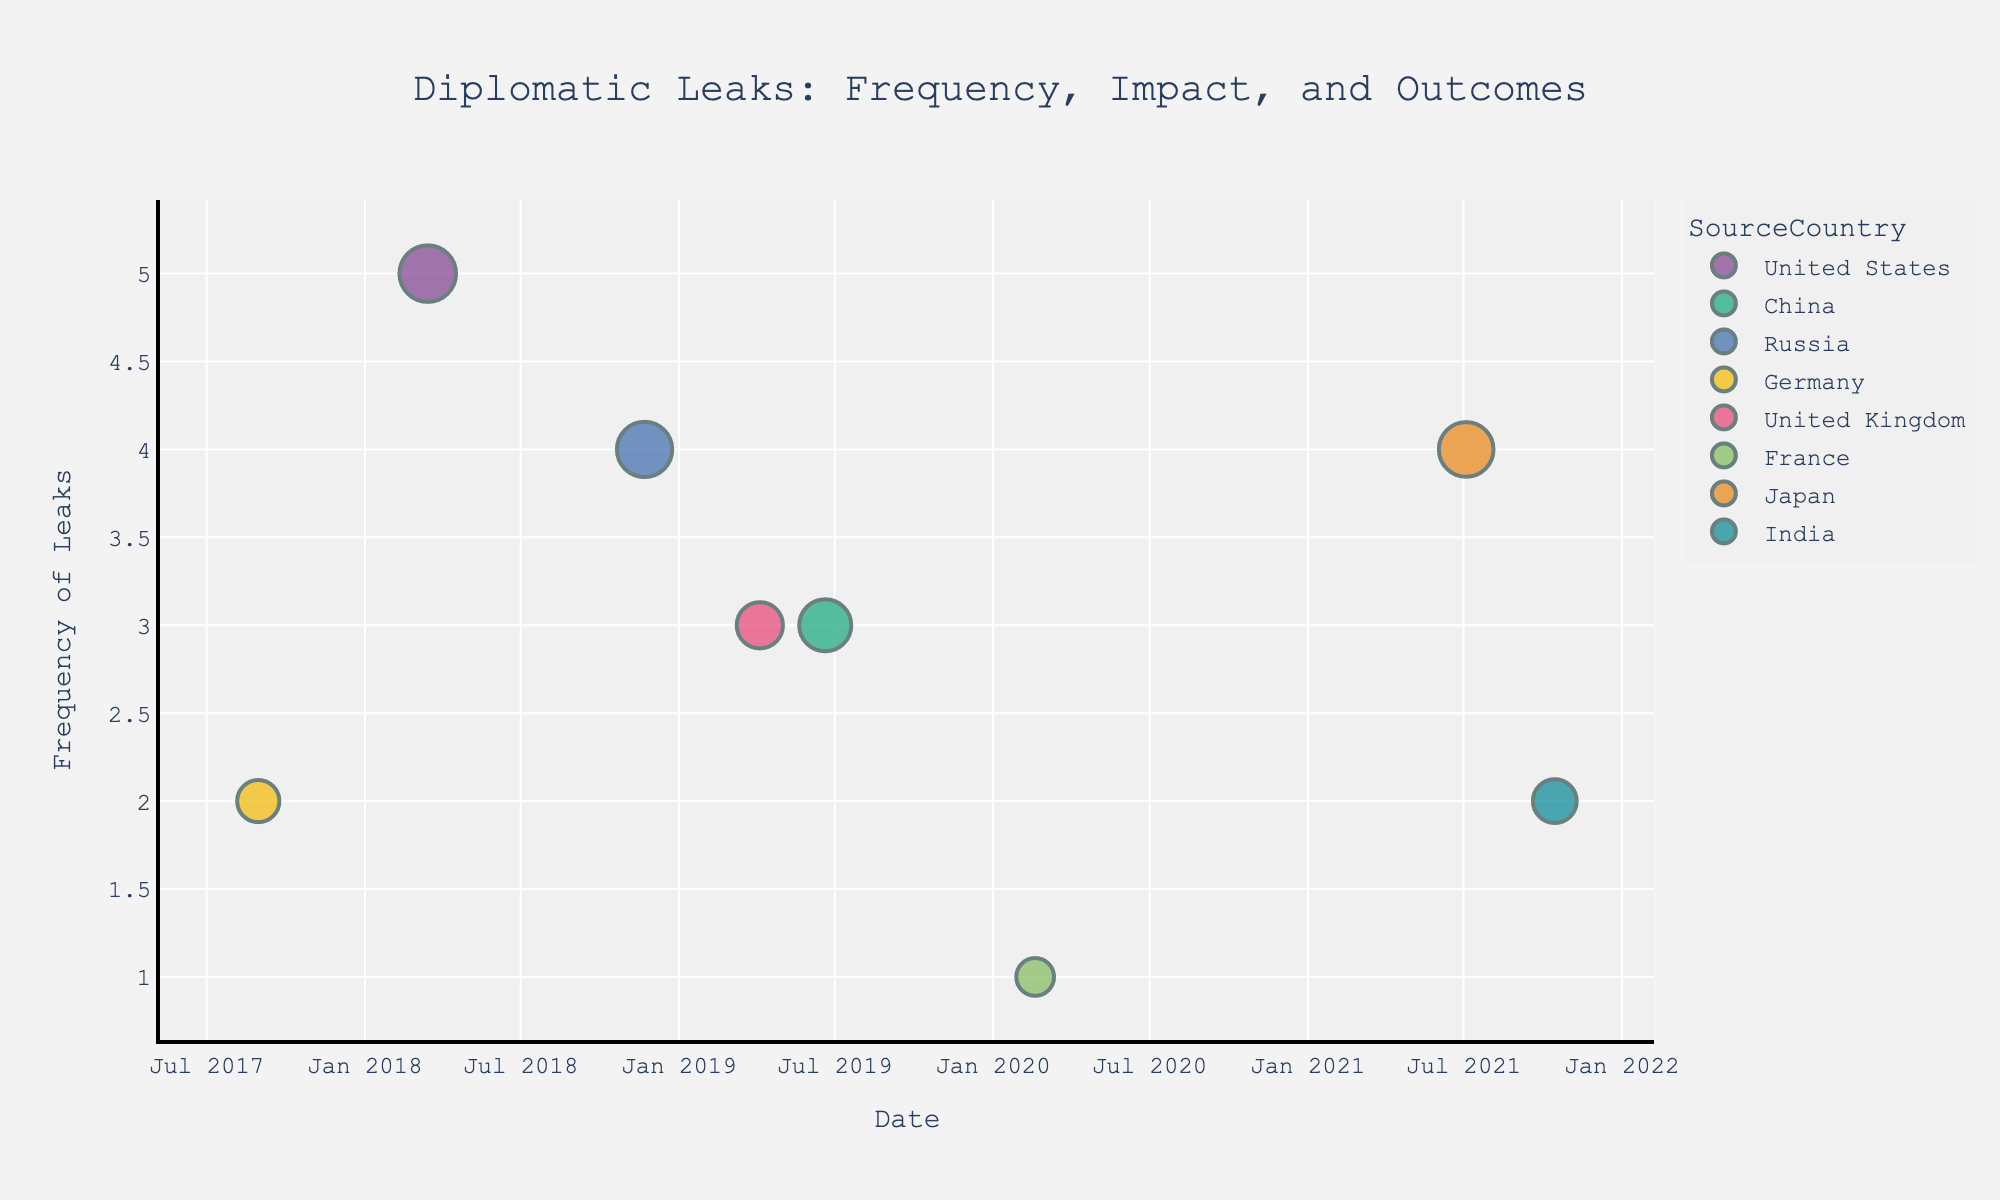what is the range of the timeline shown on the figure? The figure shows the timeline on the x-axis, marked with the dates from the earliest year to the latest. By examining the x-axis, you can identify the first and last dates displayed.
Answer: 2017-08-30 to 2021-10-15 Which country has the highest frequency of leaks? The scatter plot uses different colors to represent countries with the frequency of leaks shown on the y-axis. The highest point on the y-axis corresponds to the country with the highest frequency of leaks.
Answer: United States What is the highest value of stock market impact observed? The scatter plot includes the stock market impact as marker sizes, so the largest marker represents the highest impact. By identifying and reading the largest marker, you can determine the highest impact value.
Answer: 4.5 How does the frequency of leaks from the United States compare with those from Russia? To answer this, look at the y-axis positions of the markers representing United States and Russia. The United States marker is at y=5, and the Russia marker is at y=4.
Answer: United States has more leaks than Russia What was the timeline date and outcome for the UK diplomatic leak? Look for the marker that represents the UK data point. The timeline (x-axis) for UK should be read directly, and the hover information or associated label can provide the outcome.
Answer: 2019-04-05, Brexit Negotiations Which source country had the leaks associated with the highest stock market volatility impact in the Technology sector? Identify the largest marker (representing the highest impact) within the Technology sector by referencing the hover or legend information and check its associated country.
Answer: United States How many diplomatic leaks occurred in the year 2019 according to the data points in the plot? By examining the x-axis and focusing on data points within the 2019 range, count the number of markers in this range.
Answer: 3 Compare the public trust in media outlets after leaks reported by the Democrats versus the Republicans. Identify the data points related to Democrats and Republicans by their colors/labels. Check and compare their respective values on the "PublicTrustInMedia" scale.
Answer: Democrats: 60, 70, 60; Republicans: 40, 65, 45 What is the general trend of social media sentiment across different platforms? Review the data points and their assigned sentiments (positive, negative, mixed) shown by their positioning, color, or hover details to identify any common trends.
Answer: Mixed sentiments are present across all platforms, with each platform having varied sentiments Which event had the highest frequency of leaks and what was its international relations outcome? Identify the marker with the highest y-axis value (frequency of leaks) and read the associated hover data for the international relations outcome.
Answer: Trade Tensions with China 